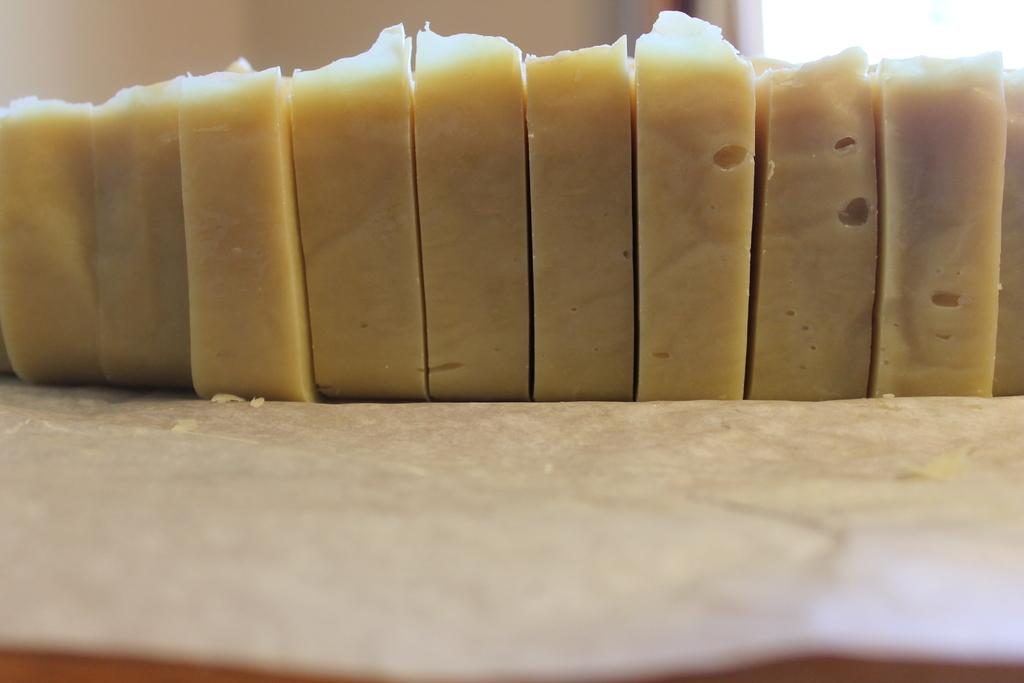What is the main subject of the image? The main subject of the image is cheese pieces. Can you describe the cheese pieces in the image? The image shows a close view of cheese pieces. What might someone do with the cheese pieces in the image? The cheese pieces could be used for snacking, cooking, or as a topping. What hobbies are the cheese pieces participating in during the image? Cheese pieces do not have hobbies, as they are inanimate objects. 